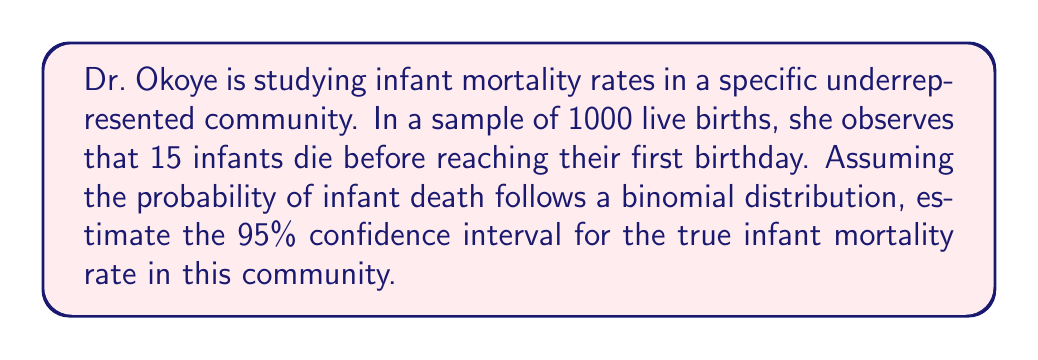Could you help me with this problem? To estimate the confidence interval for the infant mortality rate, we'll use the normal approximation to the binomial distribution, which is appropriate given our large sample size.

1. Calculate the point estimate (p̂) of the infant mortality rate:
   $\hat{p} = \frac{\text{number of events}}{\text{total sample size}} = \frac{15}{1000} = 0.015$

2. Calculate the standard error (SE) of the estimate:
   $SE = \sqrt{\frac{\hat{p}(1-\hat{p})}{n}} = \sqrt{\frac{0.015(1-0.015)}{1000}} \approx 0.00385$

3. For a 95% confidence interval, we use a z-score of 1.96 (from the standard normal distribution).

4. Calculate the margin of error:
   $\text{Margin of Error} = 1.96 \times SE \approx 1.96 \times 0.00385 \approx 0.00755$

5. Compute the confidence interval:
   Lower bound: $\hat{p} - \text{Margin of Error} = 0.015 - 0.00755 \approx 0.00745$
   Upper bound: $\hat{p} + \text{Margin of Error} = 0.015 + 0.00755 \approx 0.02255$

6. Convert to deaths per 1000 live births:
   Lower bound: $0.00745 \times 1000 \approx 7.45$
   Upper bound: $0.02255 \times 1000 \approx 22.55$

Therefore, we can estimate with 95% confidence that the true infant mortality rate in this community is between 7.45 and 22.55 deaths per 1000 live births.
Answer: The 95% confidence interval for the infant mortality rate is approximately (7.45, 22.55) deaths per 1000 live births. 